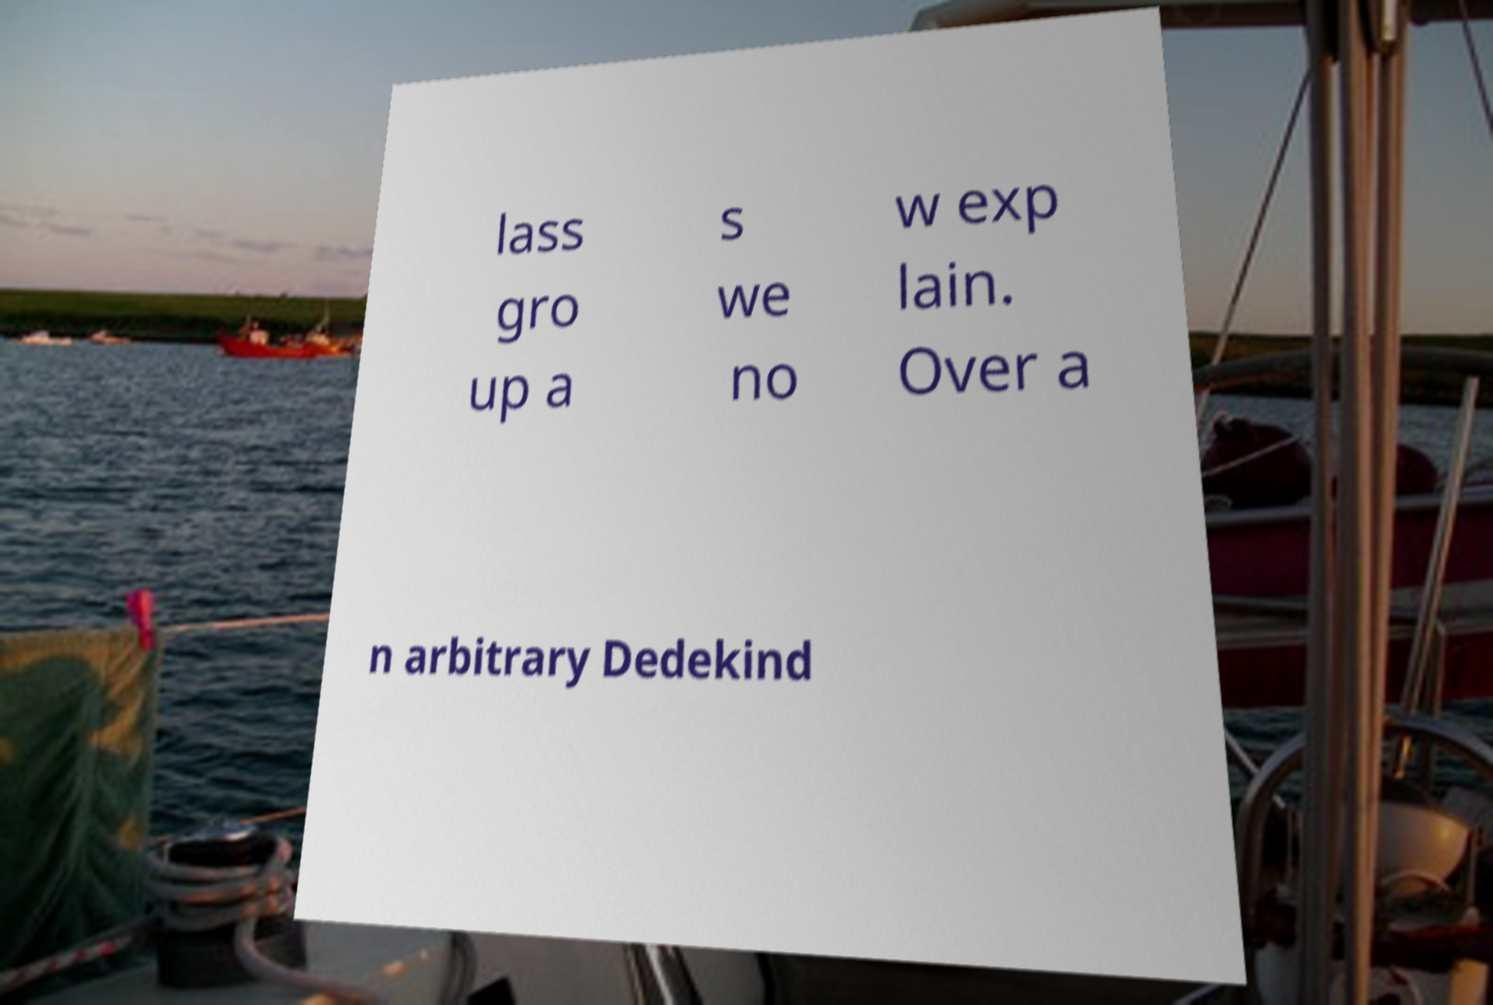Can you read and provide the text displayed in the image?This photo seems to have some interesting text. Can you extract and type it out for me? lass gro up a s we no w exp lain. Over a n arbitrary Dedekind 